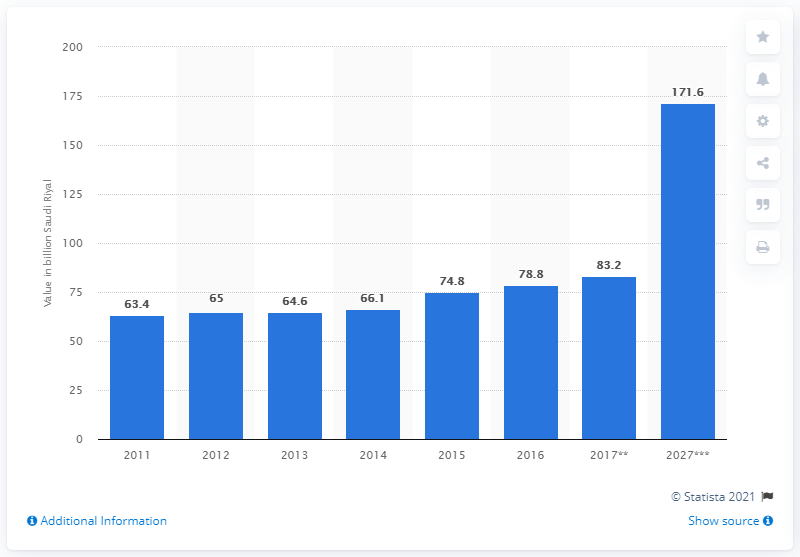Draw attention to some important aspects in this diagram. According to forecasts, the direct tourism contribution to the Gross Domestic Product (GDP) of Saudi Arabia is expected to reach 171.6 Saudi Riyal by 2027. 